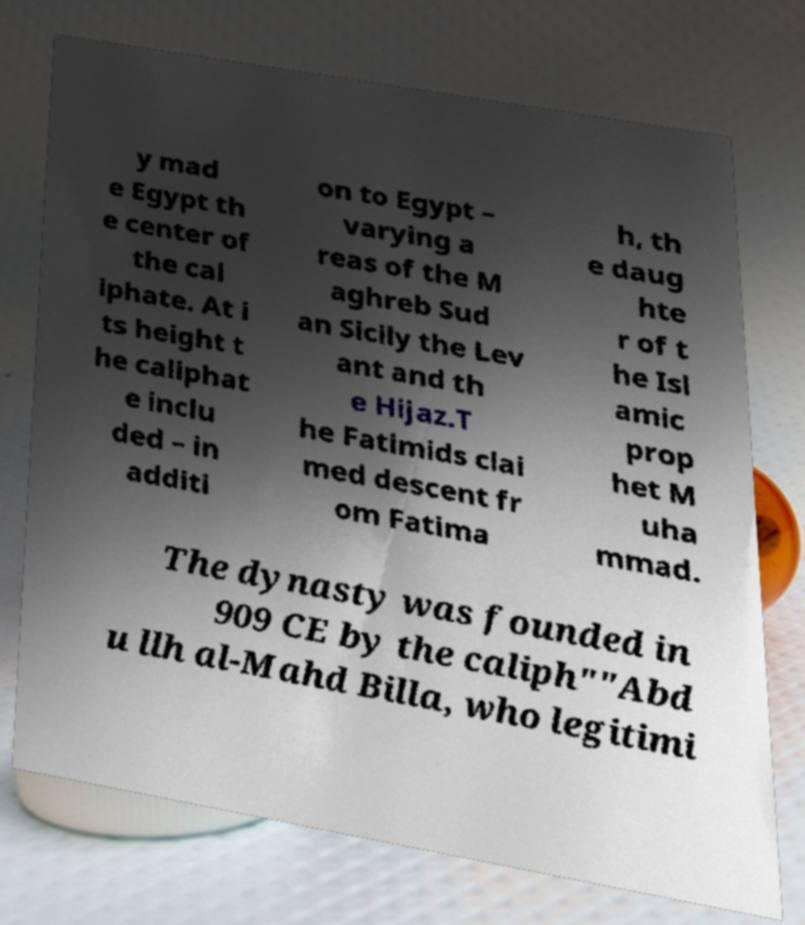I need the written content from this picture converted into text. Can you do that? y mad e Egypt th e center of the cal iphate. At i ts height t he caliphat e inclu ded – in additi on to Egypt – varying a reas of the M aghreb Sud an Sicily the Lev ant and th e Hijaz.T he Fatimids clai med descent fr om Fatima h, th e daug hte r of t he Isl amic prop het M uha mmad. The dynasty was founded in 909 CE by the caliph""Abd u llh al-Mahd Billa, who legitimi 